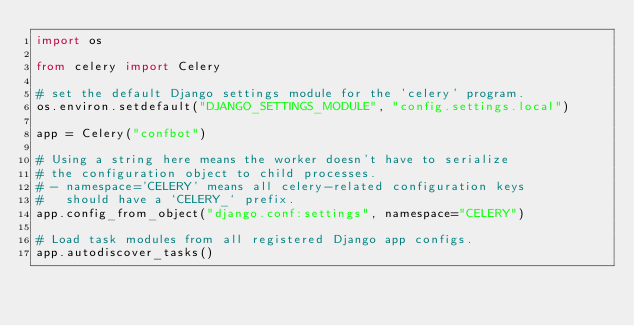Convert code to text. <code><loc_0><loc_0><loc_500><loc_500><_Python_>import os

from celery import Celery

# set the default Django settings module for the 'celery' program.
os.environ.setdefault("DJANGO_SETTINGS_MODULE", "config.settings.local")

app = Celery("confbot")

# Using a string here means the worker doesn't have to serialize
# the configuration object to child processes.
# - namespace='CELERY' means all celery-related configuration keys
#   should have a `CELERY_` prefix.
app.config_from_object("django.conf:settings", namespace="CELERY")

# Load task modules from all registered Django app configs.
app.autodiscover_tasks()
</code> 